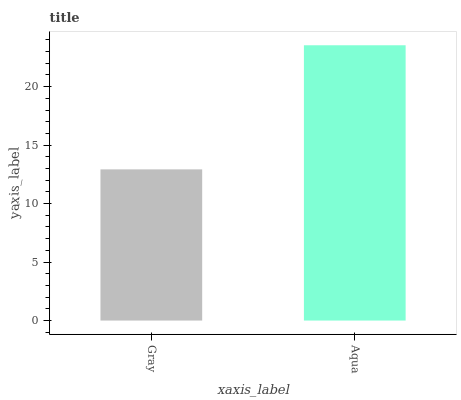Is Gray the minimum?
Answer yes or no. Yes. Is Aqua the maximum?
Answer yes or no. Yes. Is Aqua the minimum?
Answer yes or no. No. Is Aqua greater than Gray?
Answer yes or no. Yes. Is Gray less than Aqua?
Answer yes or no. Yes. Is Gray greater than Aqua?
Answer yes or no. No. Is Aqua less than Gray?
Answer yes or no. No. Is Aqua the high median?
Answer yes or no. Yes. Is Gray the low median?
Answer yes or no. Yes. Is Gray the high median?
Answer yes or no. No. Is Aqua the low median?
Answer yes or no. No. 